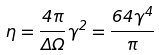<formula> <loc_0><loc_0><loc_500><loc_500>\eta = \frac { 4 \pi } { \Delta \Omega } \gamma ^ { 2 } = \frac { 6 4 \gamma ^ { 4 } } { \pi }</formula> 